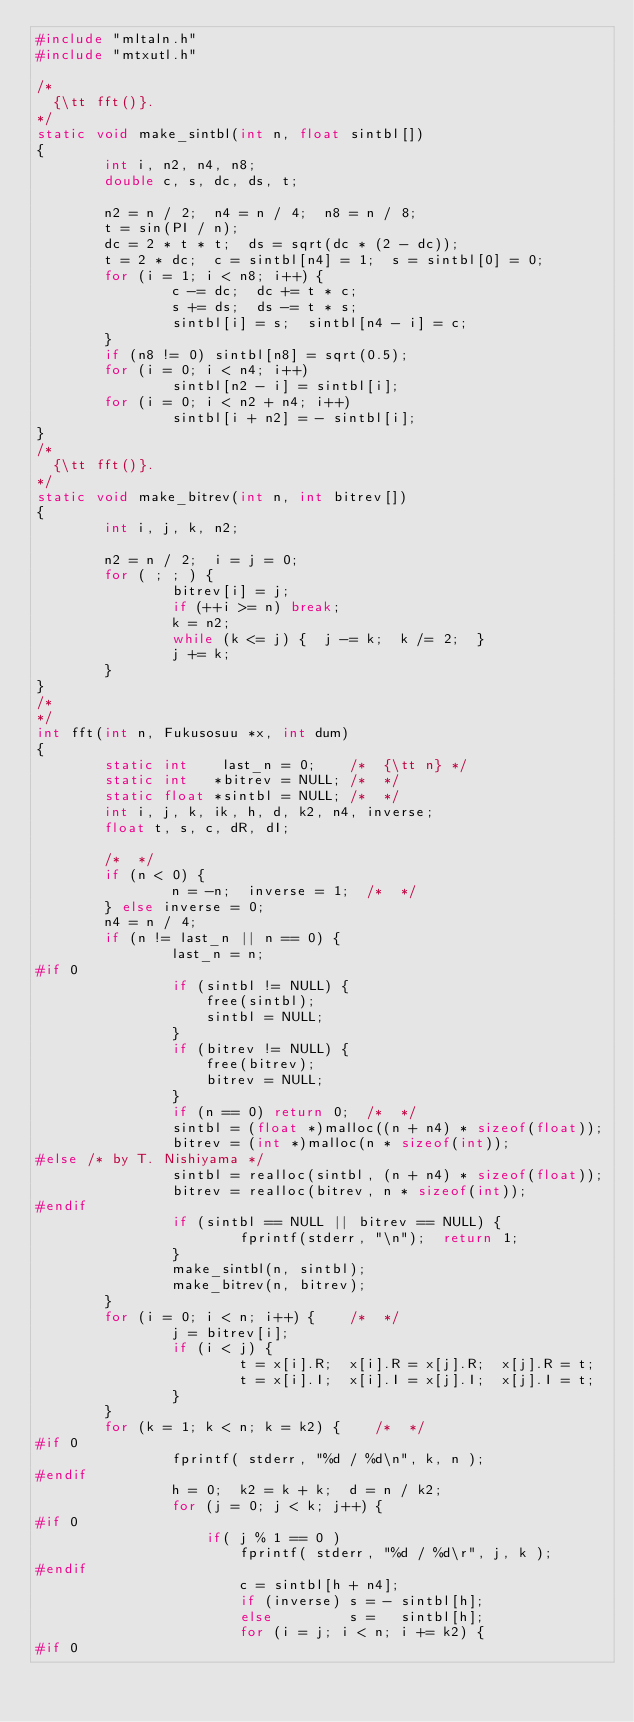Convert code to text. <code><loc_0><loc_0><loc_500><loc_500><_C_>#include "mltaln.h"
#include "mtxutl.h"

/*
  {\tt fft()}.
*/
static void make_sintbl(int n, float sintbl[])
{
        int i, n2, n4, n8;
        double c, s, dc, ds, t;

        n2 = n / 2;  n4 = n / 4;  n8 = n / 8;
        t = sin(PI / n);
        dc = 2 * t * t;  ds = sqrt(dc * (2 - dc));
        t = 2 * dc;  c = sintbl[n4] = 1;  s = sintbl[0] = 0;
        for (i = 1; i < n8; i++) {
                c -= dc;  dc += t * c;
                s += ds;  ds -= t * s;
                sintbl[i] = s;  sintbl[n4 - i] = c;
        }
        if (n8 != 0) sintbl[n8] = sqrt(0.5);
        for (i = 0; i < n4; i++)
                sintbl[n2 - i] = sintbl[i];
        for (i = 0; i < n2 + n4; i++)
                sintbl[i + n2] = - sintbl[i];
}
/*
  {\tt fft()}.
*/
static void make_bitrev(int n, int bitrev[])
{
        int i, j, k, n2;

        n2 = n / 2;  i = j = 0;
        for ( ; ; ) {
                bitrev[i] = j;
                if (++i >= n) break;
                k = n2;
                while (k <= j) {  j -= k;  k /= 2;  }
                j += k;
        }
}
/*
*/
int fft(int n, Fukusosuu *x, int dum)
{
        static int    last_n = 0;    /*  {\tt n} */
        static int   *bitrev = NULL; /*  */
        static float *sintbl = NULL; /*  */
        int i, j, k, ik, h, d, k2, n4, inverse;
        float t, s, c, dR, dI;

        /*  */
        if (n < 0) {
                n = -n;  inverse = 1;  /*  */
        } else inverse = 0;
        n4 = n / 4;
        if (n != last_n || n == 0) {
                last_n = n;
#if 0
                if (sintbl != NULL) {
					free(sintbl);
					sintbl = NULL;
				}
                if (bitrev != NULL) {
					free(bitrev);
					bitrev = NULL;
				}
                if (n == 0) return 0;  /*  */
                sintbl = (float *)malloc((n + n4) * sizeof(float));
                bitrev = (int *)malloc(n * sizeof(int));
#else /* by T. Nishiyama */
				sintbl = realloc(sintbl, (n + n4) * sizeof(float));
				bitrev = realloc(bitrev, n * sizeof(int));
#endif
                if (sintbl == NULL || bitrev == NULL) {
                        fprintf(stderr, "\n");  return 1;
                }
                make_sintbl(n, sintbl);
                make_bitrev(n, bitrev);
        }
        for (i = 0; i < n; i++) {    /*  */
                j = bitrev[i];
                if (i < j) {
                        t = x[i].R;  x[i].R = x[j].R;  x[j].R = t;
                        t = x[i].I;  x[i].I = x[j].I;  x[j].I = t;
                }
        }
        for (k = 1; k < n; k = k2) {    /*  */
#if 0
				fprintf( stderr, "%d / %d\n", k, n );
#endif
                h = 0;  k2 = k + k;  d = n / k2;
                for (j = 0; j < k; j++) {
#if 0
					if( j % 1 == 0 )
						fprintf( stderr, "%d / %d\r", j, k );
#endif
                        c = sintbl[h + n4];
                        if (inverse) s = - sintbl[h];
                        else         s =   sintbl[h];
                        for (i = j; i < n; i += k2) {
#if 0</code> 